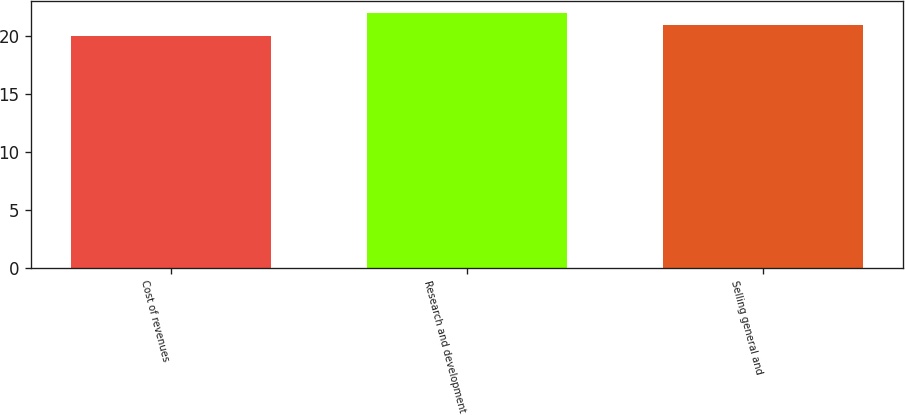Convert chart to OTSL. <chart><loc_0><loc_0><loc_500><loc_500><bar_chart><fcel>Cost of revenues<fcel>Research and development<fcel>Selling general and<nl><fcel>20<fcel>22<fcel>21<nl></chart> 